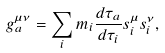Convert formula to latex. <formula><loc_0><loc_0><loc_500><loc_500>g _ { a } ^ { \mu \nu } = \sum _ { i } m _ { i } \frac { d \tau _ { a } } { d \tau _ { i } } s _ { i } ^ { \mu } s _ { i } ^ { \nu } ,</formula> 